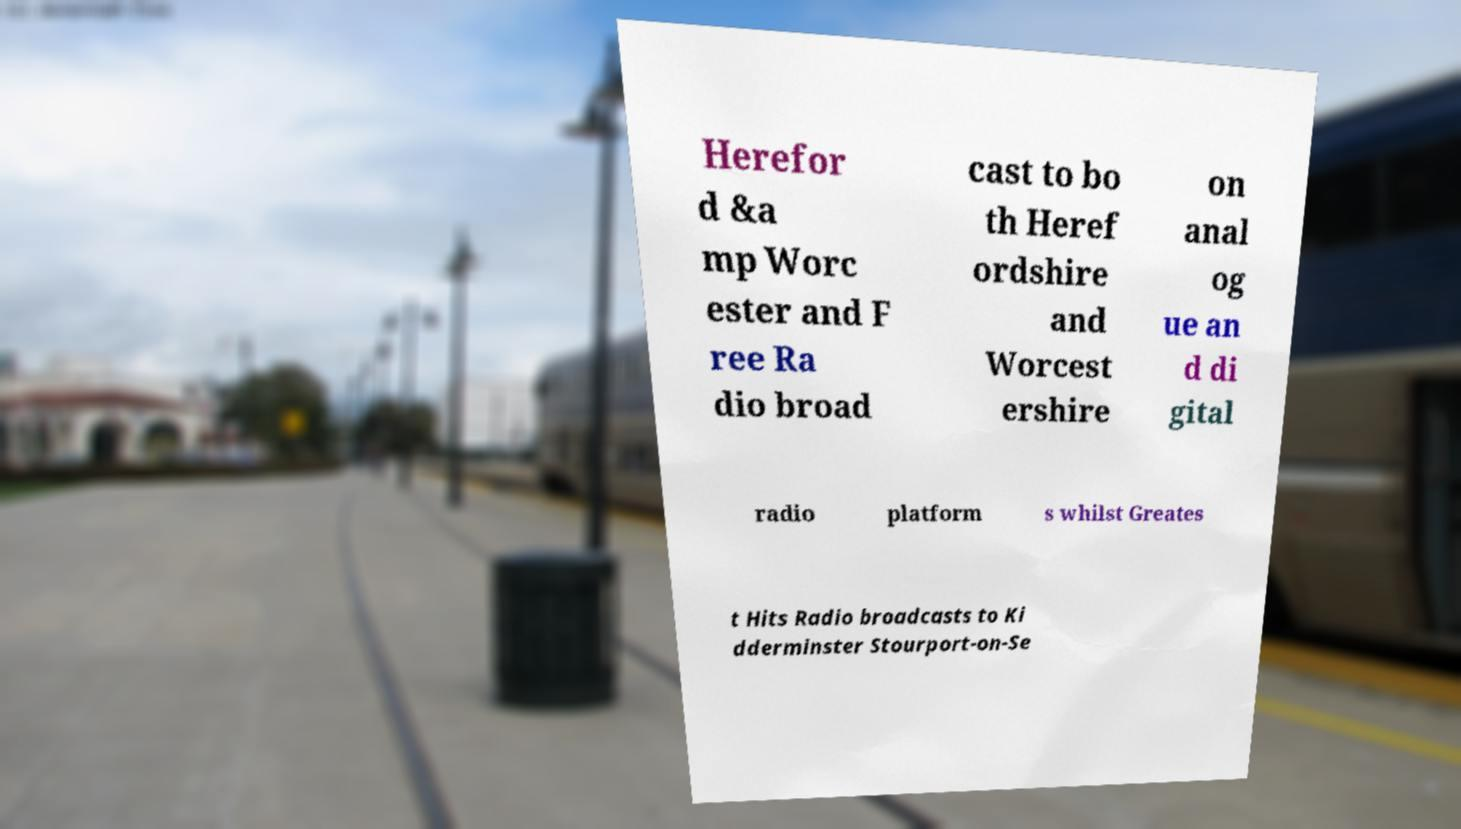Could you extract and type out the text from this image? Herefor d &a mp Worc ester and F ree Ra dio broad cast to bo th Heref ordshire and Worcest ershire on anal og ue an d di gital radio platform s whilst Greates t Hits Radio broadcasts to Ki dderminster Stourport-on-Se 